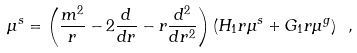Convert formula to latex. <formula><loc_0><loc_0><loc_500><loc_500>\mu ^ { s } = \left ( \frac { m ^ { 2 } } { r } - 2 \frac { d } { d r } - r \frac { d ^ { 2 } } { d r ^ { 2 } } \right ) ( H _ { 1 } r \mu ^ { s } + G _ { 1 } r \mu ^ { g } ) \ ,</formula> 